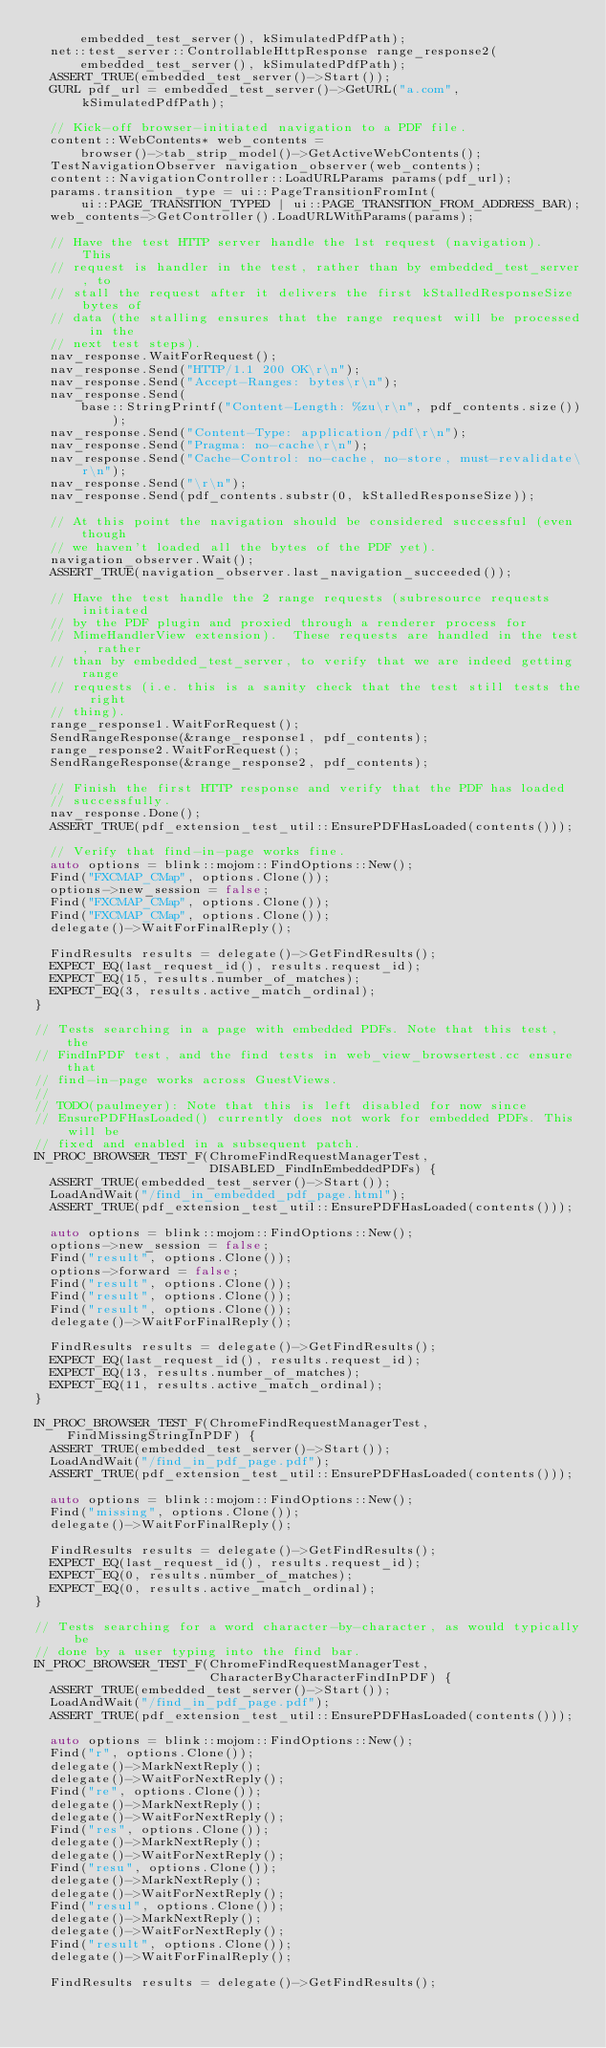<code> <loc_0><loc_0><loc_500><loc_500><_C++_>      embedded_test_server(), kSimulatedPdfPath);
  net::test_server::ControllableHttpResponse range_response2(
      embedded_test_server(), kSimulatedPdfPath);
  ASSERT_TRUE(embedded_test_server()->Start());
  GURL pdf_url = embedded_test_server()->GetURL("a.com", kSimulatedPdfPath);

  // Kick-off browser-initiated navigation to a PDF file.
  content::WebContents* web_contents =
      browser()->tab_strip_model()->GetActiveWebContents();
  TestNavigationObserver navigation_observer(web_contents);
  content::NavigationController::LoadURLParams params(pdf_url);
  params.transition_type = ui::PageTransitionFromInt(
      ui::PAGE_TRANSITION_TYPED | ui::PAGE_TRANSITION_FROM_ADDRESS_BAR);
  web_contents->GetController().LoadURLWithParams(params);

  // Have the test HTTP server handle the 1st request (navigation).  This
  // request is handler in the test, rather than by embedded_test_server, to
  // stall the request after it delivers the first kStalledResponseSize bytes of
  // data (the stalling ensures that the range request will be processed in the
  // next test steps).
  nav_response.WaitForRequest();
  nav_response.Send("HTTP/1.1 200 OK\r\n");
  nav_response.Send("Accept-Ranges: bytes\r\n");
  nav_response.Send(
      base::StringPrintf("Content-Length: %zu\r\n", pdf_contents.size()));
  nav_response.Send("Content-Type: application/pdf\r\n");
  nav_response.Send("Pragma: no-cache\r\n");
  nav_response.Send("Cache-Control: no-cache, no-store, must-revalidate\r\n");
  nav_response.Send("\r\n");
  nav_response.Send(pdf_contents.substr(0, kStalledResponseSize));

  // At this point the navigation should be considered successful (even though
  // we haven't loaded all the bytes of the PDF yet).
  navigation_observer.Wait();
  ASSERT_TRUE(navigation_observer.last_navigation_succeeded());

  // Have the test handle the 2 range requests (subresource requests initiated
  // by the PDF plugin and proxied through a renderer process for
  // MimeHandlerView extension).  These requests are handled in the test, rather
  // than by embedded_test_server, to verify that we are indeed getting range
  // requests (i.e. this is a sanity check that the test still tests the right
  // thing).
  range_response1.WaitForRequest();
  SendRangeResponse(&range_response1, pdf_contents);
  range_response2.WaitForRequest();
  SendRangeResponse(&range_response2, pdf_contents);

  // Finish the first HTTP response and verify that the PDF has loaded
  // successfully.
  nav_response.Done();
  ASSERT_TRUE(pdf_extension_test_util::EnsurePDFHasLoaded(contents()));

  // Verify that find-in-page works fine.
  auto options = blink::mojom::FindOptions::New();
  Find("FXCMAP_CMap", options.Clone());
  options->new_session = false;
  Find("FXCMAP_CMap", options.Clone());
  Find("FXCMAP_CMap", options.Clone());
  delegate()->WaitForFinalReply();

  FindResults results = delegate()->GetFindResults();
  EXPECT_EQ(last_request_id(), results.request_id);
  EXPECT_EQ(15, results.number_of_matches);
  EXPECT_EQ(3, results.active_match_ordinal);
}

// Tests searching in a page with embedded PDFs. Note that this test, the
// FindInPDF test, and the find tests in web_view_browsertest.cc ensure that
// find-in-page works across GuestViews.
//
// TODO(paulmeyer): Note that this is left disabled for now since
// EnsurePDFHasLoaded() currently does not work for embedded PDFs. This will be
// fixed and enabled in a subsequent patch.
IN_PROC_BROWSER_TEST_F(ChromeFindRequestManagerTest,
                       DISABLED_FindInEmbeddedPDFs) {
  ASSERT_TRUE(embedded_test_server()->Start());
  LoadAndWait("/find_in_embedded_pdf_page.html");
  ASSERT_TRUE(pdf_extension_test_util::EnsurePDFHasLoaded(contents()));

  auto options = blink::mojom::FindOptions::New();
  options->new_session = false;
  Find("result", options.Clone());
  options->forward = false;
  Find("result", options.Clone());
  Find("result", options.Clone());
  Find("result", options.Clone());
  delegate()->WaitForFinalReply();

  FindResults results = delegate()->GetFindResults();
  EXPECT_EQ(last_request_id(), results.request_id);
  EXPECT_EQ(13, results.number_of_matches);
  EXPECT_EQ(11, results.active_match_ordinal);
}

IN_PROC_BROWSER_TEST_F(ChromeFindRequestManagerTest, FindMissingStringInPDF) {
  ASSERT_TRUE(embedded_test_server()->Start());
  LoadAndWait("/find_in_pdf_page.pdf");
  ASSERT_TRUE(pdf_extension_test_util::EnsurePDFHasLoaded(contents()));

  auto options = blink::mojom::FindOptions::New();
  Find("missing", options.Clone());
  delegate()->WaitForFinalReply();

  FindResults results = delegate()->GetFindResults();
  EXPECT_EQ(last_request_id(), results.request_id);
  EXPECT_EQ(0, results.number_of_matches);
  EXPECT_EQ(0, results.active_match_ordinal);
}

// Tests searching for a word character-by-character, as would typically be
// done by a user typing into the find bar.
IN_PROC_BROWSER_TEST_F(ChromeFindRequestManagerTest,
                       CharacterByCharacterFindInPDF) {
  ASSERT_TRUE(embedded_test_server()->Start());
  LoadAndWait("/find_in_pdf_page.pdf");
  ASSERT_TRUE(pdf_extension_test_util::EnsurePDFHasLoaded(contents()));

  auto options = blink::mojom::FindOptions::New();
  Find("r", options.Clone());
  delegate()->MarkNextReply();
  delegate()->WaitForNextReply();
  Find("re", options.Clone());
  delegate()->MarkNextReply();
  delegate()->WaitForNextReply();
  Find("res", options.Clone());
  delegate()->MarkNextReply();
  delegate()->WaitForNextReply();
  Find("resu", options.Clone());
  delegate()->MarkNextReply();
  delegate()->WaitForNextReply();
  Find("resul", options.Clone());
  delegate()->MarkNextReply();
  delegate()->WaitForNextReply();
  Find("result", options.Clone());
  delegate()->WaitForFinalReply();

  FindResults results = delegate()->GetFindResults();</code> 